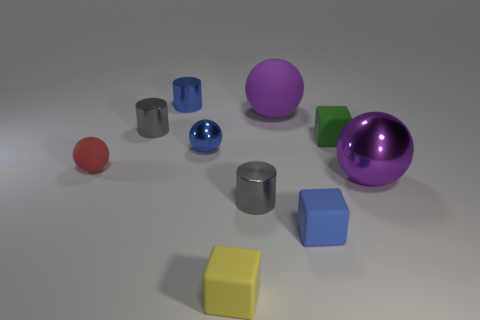What shape is the big object that is made of the same material as the small blue ball?
Ensure brevity in your answer.  Sphere. Is the number of purple metal objects less than the number of big gray rubber objects?
Provide a succinct answer. No. The small cylinder that is in front of the purple rubber object and to the left of the tiny blue metal ball is made of what material?
Make the answer very short. Metal. There is a matte ball that is behind the red sphere left of the cylinder behind the purple rubber ball; what size is it?
Provide a short and direct response. Large. Do the blue rubber thing and the gray metallic thing that is behind the small green object have the same shape?
Keep it short and to the point. No. What number of metal cylinders are both behind the small matte sphere and in front of the purple matte ball?
Make the answer very short. 1. What number of brown objects are big shiny spheres or tiny metallic objects?
Ensure brevity in your answer.  0. There is a cylinder in front of the small rubber ball; does it have the same color as the big sphere behind the small blue metallic ball?
Give a very brief answer. No. What is the color of the sphere that is behind the tiny matte cube that is behind the small gray shiny cylinder on the right side of the blue metal ball?
Provide a short and direct response. Purple. Are there any small green matte cubes that are on the right side of the tiny cube behind the small red thing?
Ensure brevity in your answer.  No. 